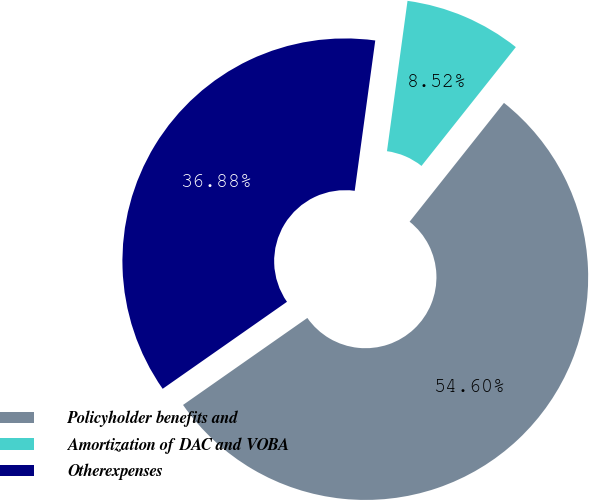Convert chart. <chart><loc_0><loc_0><loc_500><loc_500><pie_chart><fcel>Policyholder benefits and<fcel>Amortization of DAC and VOBA<fcel>Otherexpenses<nl><fcel>54.6%<fcel>8.52%<fcel>36.88%<nl></chart> 